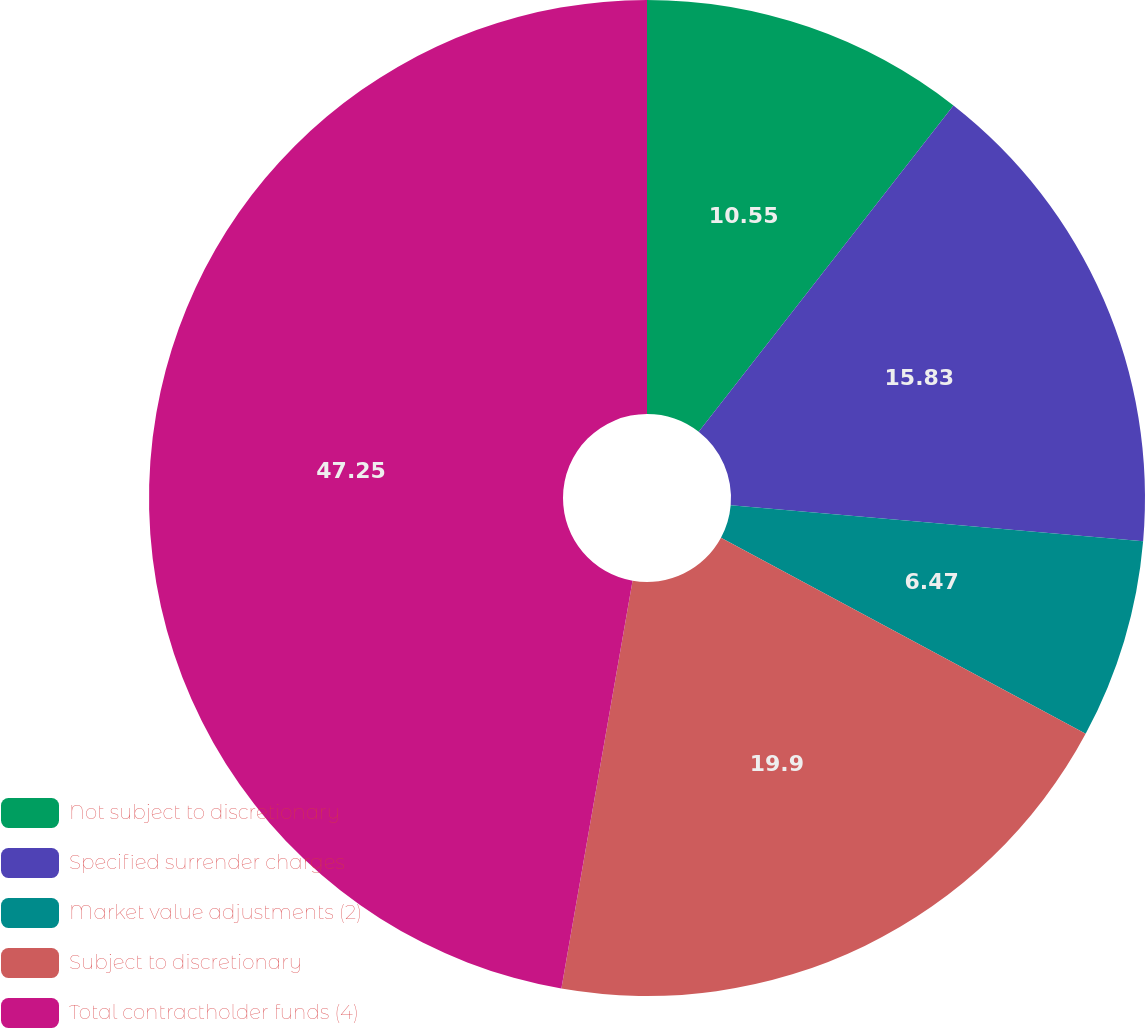<chart> <loc_0><loc_0><loc_500><loc_500><pie_chart><fcel>Not subject to discretionary<fcel>Specified surrender charges<fcel>Market value adjustments (2)<fcel>Subject to discretionary<fcel>Total contractholder funds (4)<nl><fcel>10.55%<fcel>15.83%<fcel>6.47%<fcel>19.9%<fcel>47.25%<nl></chart> 